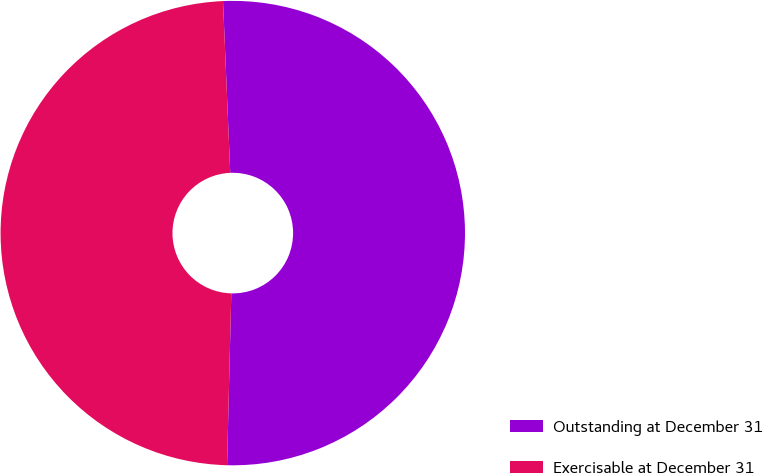Convert chart. <chart><loc_0><loc_0><loc_500><loc_500><pie_chart><fcel>Outstanding at December 31<fcel>Exercisable at December 31<nl><fcel>51.06%<fcel>48.94%<nl></chart> 